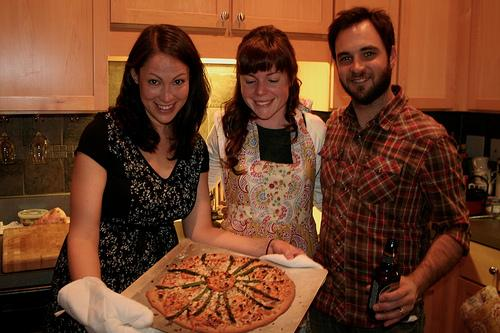How are the people feeling while holding the food? happy 